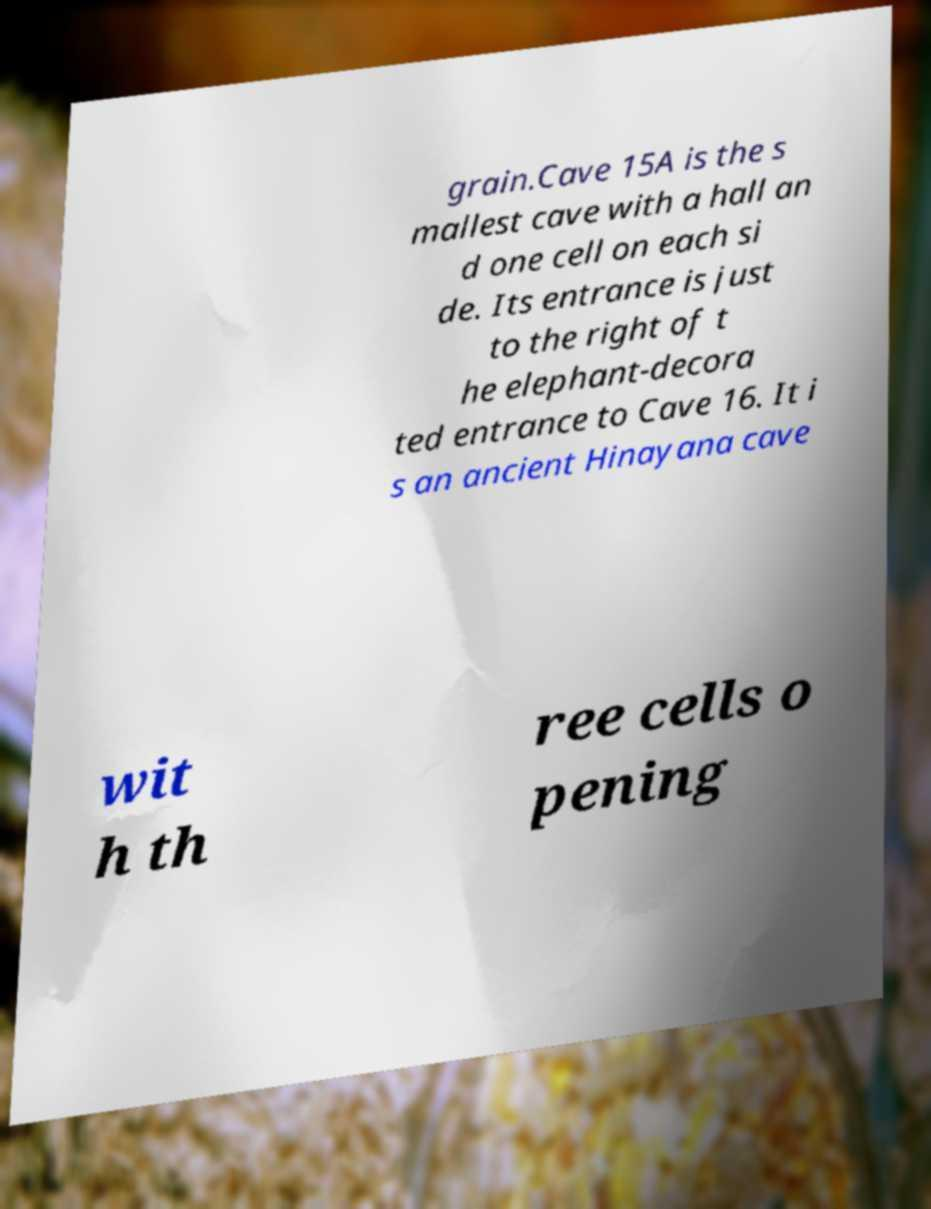What messages or text are displayed in this image? I need them in a readable, typed format. grain.Cave 15A is the s mallest cave with a hall an d one cell on each si de. Its entrance is just to the right of t he elephant-decora ted entrance to Cave 16. It i s an ancient Hinayana cave wit h th ree cells o pening 